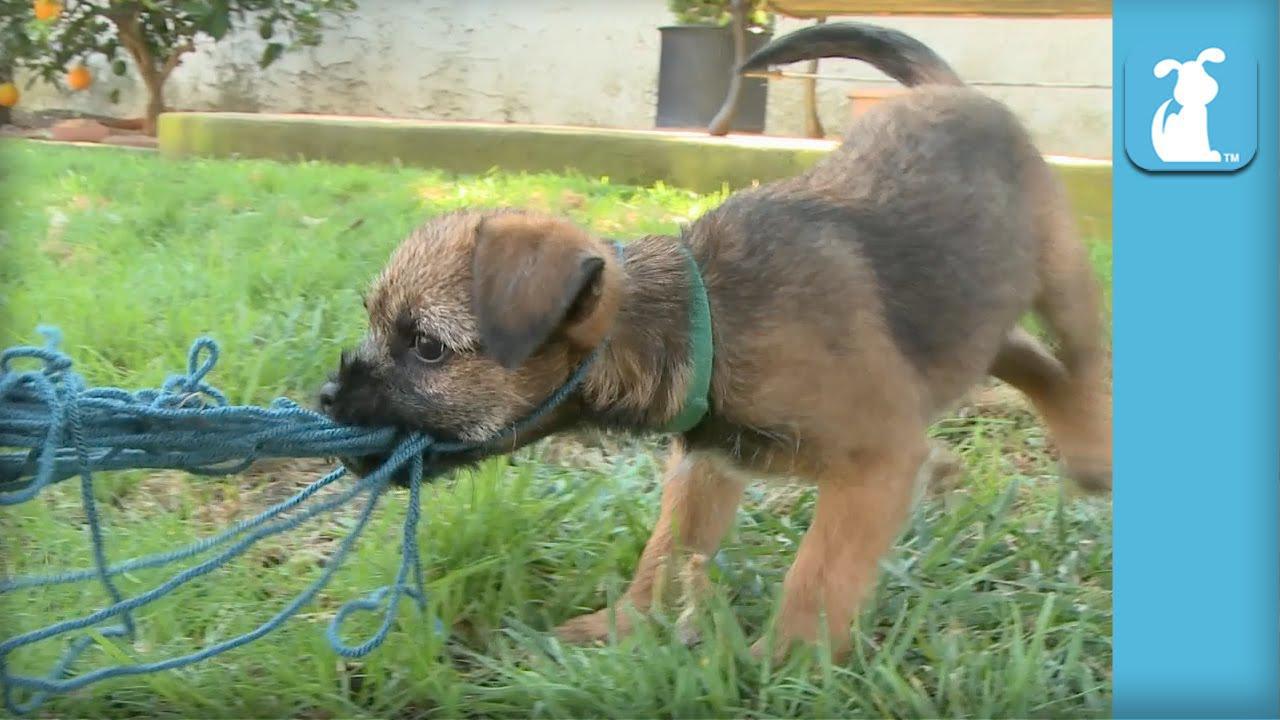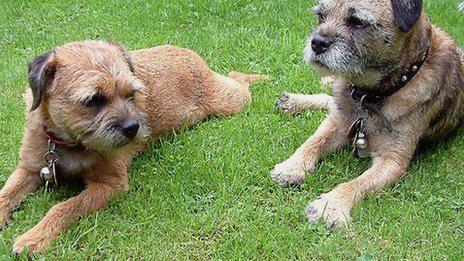The first image is the image on the left, the second image is the image on the right. Considering the images on both sides, is "An image shows two dogs together outdoors, and at least one dog is standing with its front paws balanced on something for support." valid? Answer yes or no. No. The first image is the image on the left, the second image is the image on the right. Assess this claim about the two images: "The dog in the image on the left is running through the grass.". Correct or not? Answer yes or no. No. 